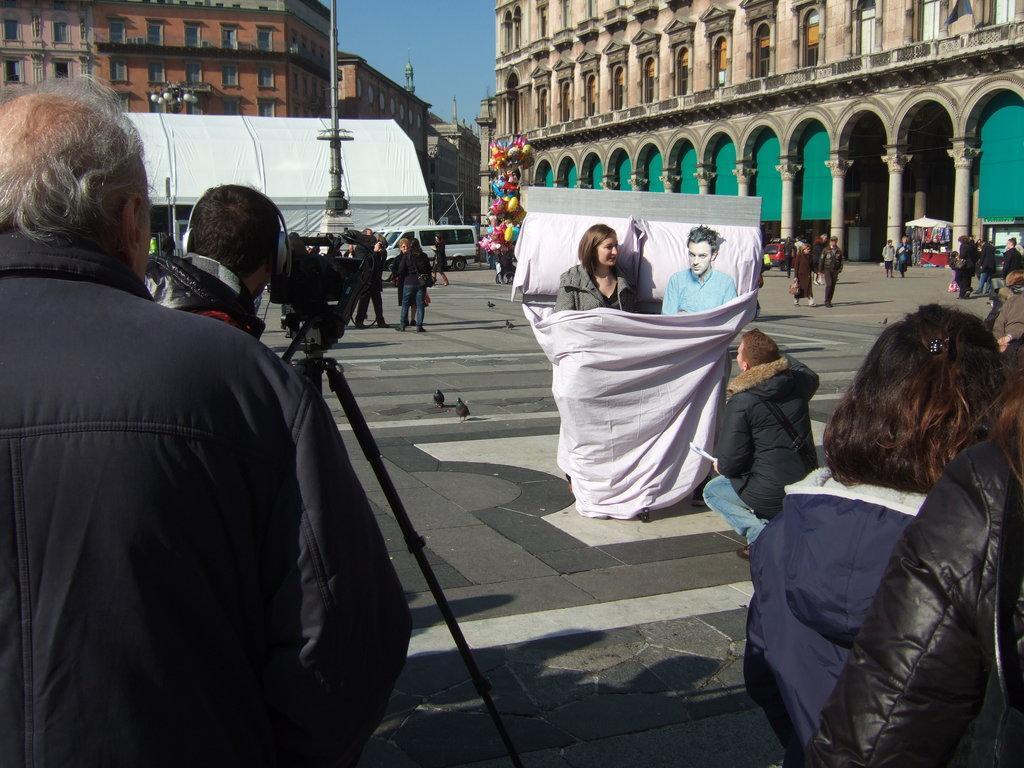Please provide a concise description of this image. In this image there are group of persons standing and walking. In the front on the left side there is a person standing and clicking a photo holding a camera which is in front of him. In the center there are persons standing and there is a pole and there is a vehicle On the right side there is a building and there are green colour curtains. In the background there is a white colour tent and there are buildings and in the center on the road there are birds. 